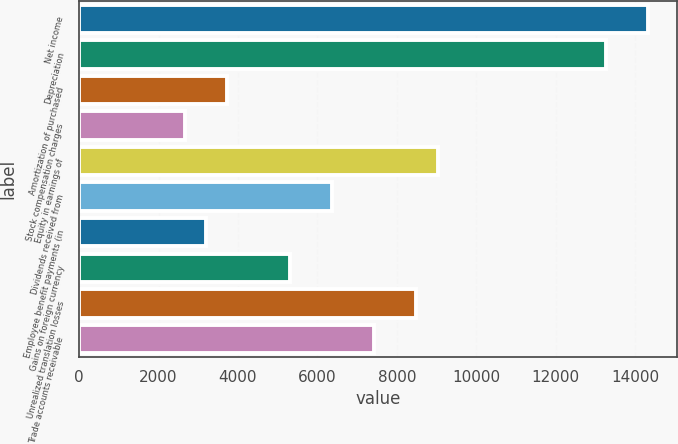Convert chart to OTSL. <chart><loc_0><loc_0><loc_500><loc_500><bar_chart><fcel>Net income<fcel>Depreciation<fcel>Amortization of purchased<fcel>Stock compensation charges<fcel>Equity in earnings of<fcel>Dividends received from<fcel>Employee benefit payments (in<fcel>Gains on foreign currency<fcel>Unrealized translation losses<fcel>Trade accounts receivable<nl><fcel>14332.6<fcel>13271<fcel>3716.6<fcel>2655<fcel>9024.6<fcel>6370.6<fcel>3185.8<fcel>5309<fcel>8493.8<fcel>7432.2<nl></chart> 